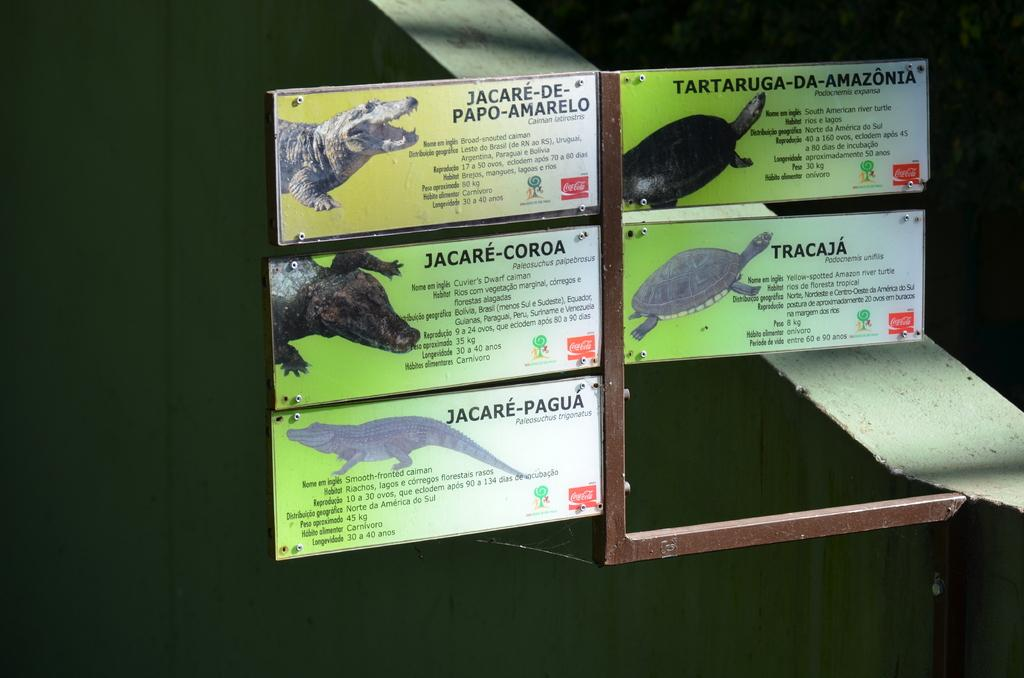What is depicted on the boards in the picture? There are boards with images in the picture. What else can be seen on the boards besides the images? There is text on the boards. What is the color of the background in the image? The background of the image is dark. What type of substance is being used by the uncle in the image? There is no uncle or substance present in the image. How does the image make you feel in terms of a particular sense? The image does not evoke a specific sense or feeling; it is a visual representation of boards with images and text. 